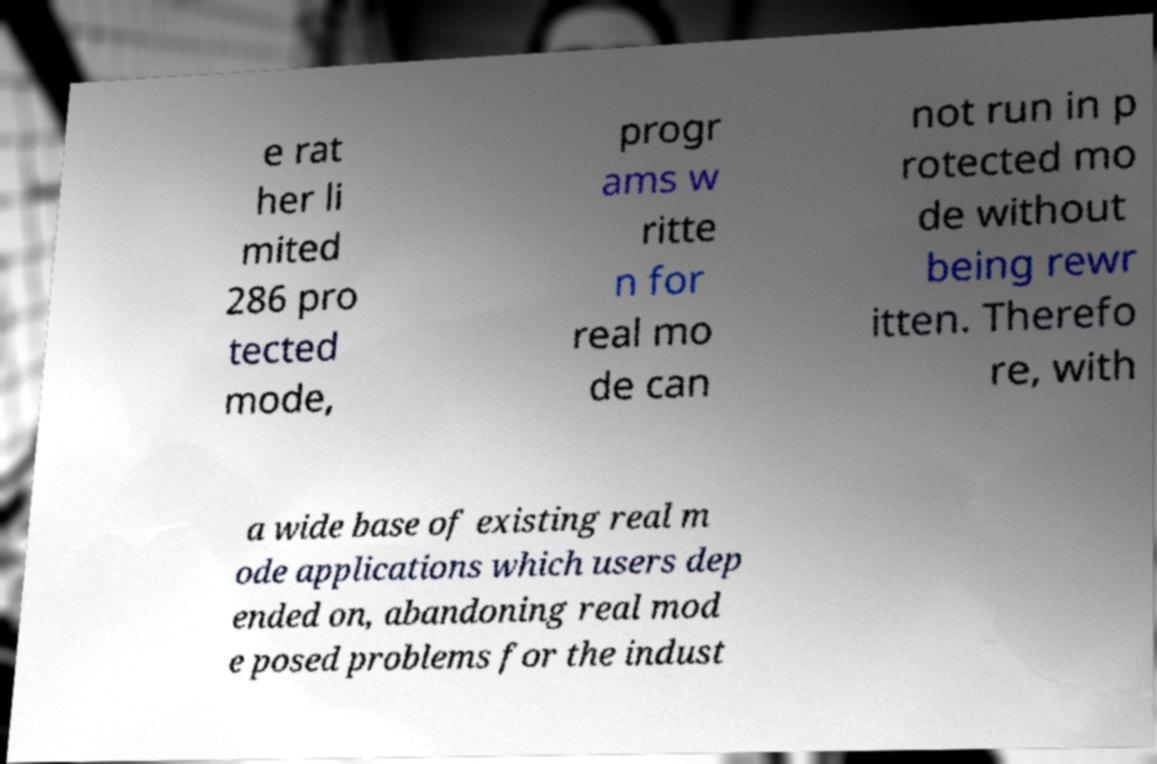I need the written content from this picture converted into text. Can you do that? e rat her li mited 286 pro tected mode, progr ams w ritte n for real mo de can not run in p rotected mo de without being rewr itten. Therefo re, with a wide base of existing real m ode applications which users dep ended on, abandoning real mod e posed problems for the indust 